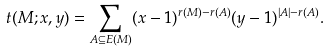Convert formula to latex. <formula><loc_0><loc_0><loc_500><loc_500>t ( M ; x , y ) = \sum _ { A \subseteq E ( M ) } ( x - 1 ) ^ { r ( M ) - r ( A ) } ( y - 1 ) ^ { | A | - r ( A ) } .</formula> 